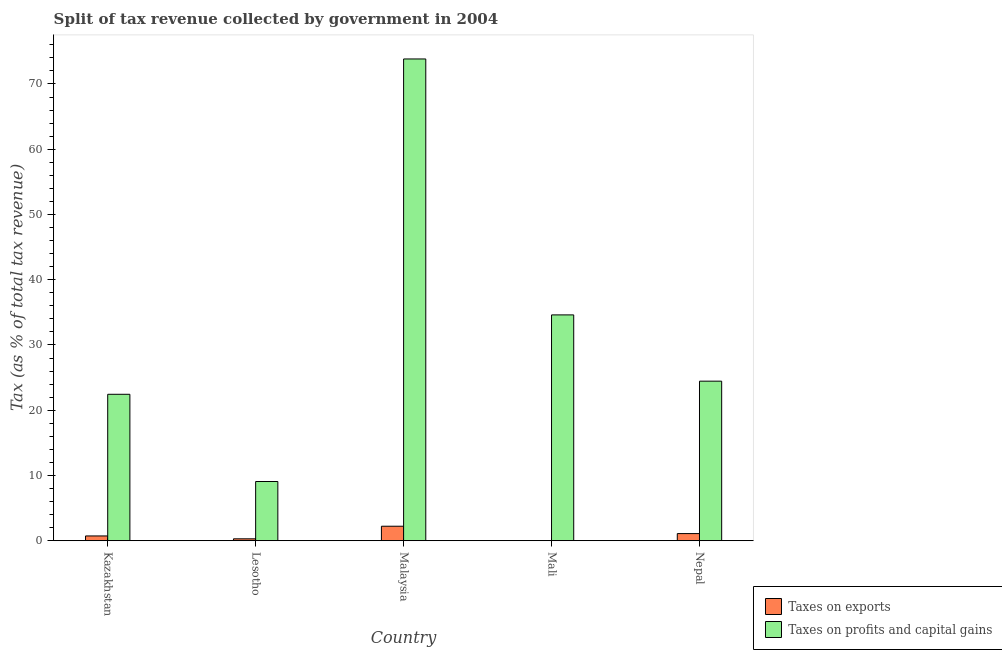How many different coloured bars are there?
Your answer should be compact. 2. Are the number of bars per tick equal to the number of legend labels?
Your answer should be very brief. Yes. How many bars are there on the 4th tick from the left?
Your response must be concise. 2. What is the label of the 3rd group of bars from the left?
Give a very brief answer. Malaysia. What is the percentage of revenue obtained from taxes on exports in Lesotho?
Offer a terse response. 0.29. Across all countries, what is the maximum percentage of revenue obtained from taxes on profits and capital gains?
Offer a very short reply. 73.83. Across all countries, what is the minimum percentage of revenue obtained from taxes on exports?
Offer a terse response. 0. In which country was the percentage of revenue obtained from taxes on exports maximum?
Provide a short and direct response. Malaysia. In which country was the percentage of revenue obtained from taxes on profits and capital gains minimum?
Offer a very short reply. Lesotho. What is the total percentage of revenue obtained from taxes on exports in the graph?
Your response must be concise. 4.34. What is the difference between the percentage of revenue obtained from taxes on exports in Kazakhstan and that in Nepal?
Your answer should be very brief. -0.36. What is the difference between the percentage of revenue obtained from taxes on exports in Malaysia and the percentage of revenue obtained from taxes on profits and capital gains in Mali?
Ensure brevity in your answer.  -32.39. What is the average percentage of revenue obtained from taxes on exports per country?
Ensure brevity in your answer.  0.87. What is the difference between the percentage of revenue obtained from taxes on profits and capital gains and percentage of revenue obtained from taxes on exports in Nepal?
Your answer should be very brief. 23.36. In how many countries, is the percentage of revenue obtained from taxes on exports greater than 34 %?
Give a very brief answer. 0. What is the ratio of the percentage of revenue obtained from taxes on profits and capital gains in Kazakhstan to that in Nepal?
Provide a short and direct response. 0.92. Is the percentage of revenue obtained from taxes on exports in Kazakhstan less than that in Nepal?
Your response must be concise. Yes. Is the difference between the percentage of revenue obtained from taxes on exports in Kazakhstan and Lesotho greater than the difference between the percentage of revenue obtained from taxes on profits and capital gains in Kazakhstan and Lesotho?
Make the answer very short. No. What is the difference between the highest and the second highest percentage of revenue obtained from taxes on profits and capital gains?
Provide a succinct answer. 39.22. What is the difference between the highest and the lowest percentage of revenue obtained from taxes on profits and capital gains?
Offer a terse response. 64.76. What does the 1st bar from the left in Malaysia represents?
Offer a terse response. Taxes on exports. What does the 1st bar from the right in Malaysia represents?
Your answer should be compact. Taxes on profits and capital gains. Are all the bars in the graph horizontal?
Offer a terse response. No. How many countries are there in the graph?
Give a very brief answer. 5. What is the difference between two consecutive major ticks on the Y-axis?
Your answer should be very brief. 10. Are the values on the major ticks of Y-axis written in scientific E-notation?
Provide a short and direct response. No. Where does the legend appear in the graph?
Your answer should be compact. Bottom right. How many legend labels are there?
Keep it short and to the point. 2. How are the legend labels stacked?
Your answer should be very brief. Vertical. What is the title of the graph?
Your answer should be very brief. Split of tax revenue collected by government in 2004. Does "Girls" appear as one of the legend labels in the graph?
Your response must be concise. No. What is the label or title of the Y-axis?
Provide a short and direct response. Tax (as % of total tax revenue). What is the Tax (as % of total tax revenue) of Taxes on exports in Kazakhstan?
Your answer should be very brief. 0.73. What is the Tax (as % of total tax revenue) in Taxes on profits and capital gains in Kazakhstan?
Give a very brief answer. 22.44. What is the Tax (as % of total tax revenue) in Taxes on exports in Lesotho?
Make the answer very short. 0.29. What is the Tax (as % of total tax revenue) in Taxes on profits and capital gains in Lesotho?
Make the answer very short. 9.07. What is the Tax (as % of total tax revenue) in Taxes on exports in Malaysia?
Offer a very short reply. 2.22. What is the Tax (as % of total tax revenue) of Taxes on profits and capital gains in Malaysia?
Your response must be concise. 73.83. What is the Tax (as % of total tax revenue) of Taxes on exports in Mali?
Your answer should be very brief. 0. What is the Tax (as % of total tax revenue) in Taxes on profits and capital gains in Mali?
Your answer should be very brief. 34.61. What is the Tax (as % of total tax revenue) in Taxes on exports in Nepal?
Keep it short and to the point. 1.09. What is the Tax (as % of total tax revenue) in Taxes on profits and capital gains in Nepal?
Provide a short and direct response. 24.45. Across all countries, what is the maximum Tax (as % of total tax revenue) of Taxes on exports?
Your answer should be very brief. 2.22. Across all countries, what is the maximum Tax (as % of total tax revenue) in Taxes on profits and capital gains?
Give a very brief answer. 73.83. Across all countries, what is the minimum Tax (as % of total tax revenue) in Taxes on exports?
Ensure brevity in your answer.  0. Across all countries, what is the minimum Tax (as % of total tax revenue) of Taxes on profits and capital gains?
Provide a succinct answer. 9.07. What is the total Tax (as % of total tax revenue) in Taxes on exports in the graph?
Give a very brief answer. 4.34. What is the total Tax (as % of total tax revenue) in Taxes on profits and capital gains in the graph?
Offer a terse response. 164.4. What is the difference between the Tax (as % of total tax revenue) in Taxes on exports in Kazakhstan and that in Lesotho?
Your answer should be compact. 0.44. What is the difference between the Tax (as % of total tax revenue) in Taxes on profits and capital gains in Kazakhstan and that in Lesotho?
Your answer should be very brief. 13.36. What is the difference between the Tax (as % of total tax revenue) in Taxes on exports in Kazakhstan and that in Malaysia?
Give a very brief answer. -1.49. What is the difference between the Tax (as % of total tax revenue) in Taxes on profits and capital gains in Kazakhstan and that in Malaysia?
Your answer should be very brief. -51.39. What is the difference between the Tax (as % of total tax revenue) of Taxes on exports in Kazakhstan and that in Mali?
Your response must be concise. 0.73. What is the difference between the Tax (as % of total tax revenue) of Taxes on profits and capital gains in Kazakhstan and that in Mali?
Offer a very short reply. -12.17. What is the difference between the Tax (as % of total tax revenue) of Taxes on exports in Kazakhstan and that in Nepal?
Provide a succinct answer. -0.36. What is the difference between the Tax (as % of total tax revenue) in Taxes on profits and capital gains in Kazakhstan and that in Nepal?
Make the answer very short. -2.01. What is the difference between the Tax (as % of total tax revenue) in Taxes on exports in Lesotho and that in Malaysia?
Give a very brief answer. -1.93. What is the difference between the Tax (as % of total tax revenue) in Taxes on profits and capital gains in Lesotho and that in Malaysia?
Offer a very short reply. -64.76. What is the difference between the Tax (as % of total tax revenue) in Taxes on exports in Lesotho and that in Mali?
Offer a terse response. 0.29. What is the difference between the Tax (as % of total tax revenue) of Taxes on profits and capital gains in Lesotho and that in Mali?
Provide a succinct answer. -25.53. What is the difference between the Tax (as % of total tax revenue) of Taxes on exports in Lesotho and that in Nepal?
Offer a very short reply. -0.8. What is the difference between the Tax (as % of total tax revenue) of Taxes on profits and capital gains in Lesotho and that in Nepal?
Provide a short and direct response. -15.38. What is the difference between the Tax (as % of total tax revenue) of Taxes on exports in Malaysia and that in Mali?
Provide a succinct answer. 2.22. What is the difference between the Tax (as % of total tax revenue) of Taxes on profits and capital gains in Malaysia and that in Mali?
Give a very brief answer. 39.22. What is the difference between the Tax (as % of total tax revenue) of Taxes on exports in Malaysia and that in Nepal?
Your answer should be very brief. 1.13. What is the difference between the Tax (as % of total tax revenue) in Taxes on profits and capital gains in Malaysia and that in Nepal?
Your answer should be compact. 49.38. What is the difference between the Tax (as % of total tax revenue) of Taxes on exports in Mali and that in Nepal?
Ensure brevity in your answer.  -1.09. What is the difference between the Tax (as % of total tax revenue) in Taxes on profits and capital gains in Mali and that in Nepal?
Your answer should be very brief. 10.16. What is the difference between the Tax (as % of total tax revenue) in Taxes on exports in Kazakhstan and the Tax (as % of total tax revenue) in Taxes on profits and capital gains in Lesotho?
Provide a succinct answer. -8.34. What is the difference between the Tax (as % of total tax revenue) in Taxes on exports in Kazakhstan and the Tax (as % of total tax revenue) in Taxes on profits and capital gains in Malaysia?
Offer a terse response. -73.1. What is the difference between the Tax (as % of total tax revenue) in Taxes on exports in Kazakhstan and the Tax (as % of total tax revenue) in Taxes on profits and capital gains in Mali?
Offer a very short reply. -33.88. What is the difference between the Tax (as % of total tax revenue) of Taxes on exports in Kazakhstan and the Tax (as % of total tax revenue) of Taxes on profits and capital gains in Nepal?
Your response must be concise. -23.72. What is the difference between the Tax (as % of total tax revenue) of Taxes on exports in Lesotho and the Tax (as % of total tax revenue) of Taxes on profits and capital gains in Malaysia?
Keep it short and to the point. -73.54. What is the difference between the Tax (as % of total tax revenue) of Taxes on exports in Lesotho and the Tax (as % of total tax revenue) of Taxes on profits and capital gains in Mali?
Your answer should be very brief. -34.32. What is the difference between the Tax (as % of total tax revenue) of Taxes on exports in Lesotho and the Tax (as % of total tax revenue) of Taxes on profits and capital gains in Nepal?
Provide a succinct answer. -24.16. What is the difference between the Tax (as % of total tax revenue) in Taxes on exports in Malaysia and the Tax (as % of total tax revenue) in Taxes on profits and capital gains in Mali?
Your response must be concise. -32.39. What is the difference between the Tax (as % of total tax revenue) in Taxes on exports in Malaysia and the Tax (as % of total tax revenue) in Taxes on profits and capital gains in Nepal?
Offer a very short reply. -22.23. What is the difference between the Tax (as % of total tax revenue) of Taxes on exports in Mali and the Tax (as % of total tax revenue) of Taxes on profits and capital gains in Nepal?
Ensure brevity in your answer.  -24.45. What is the average Tax (as % of total tax revenue) of Taxes on exports per country?
Ensure brevity in your answer.  0.87. What is the average Tax (as % of total tax revenue) in Taxes on profits and capital gains per country?
Ensure brevity in your answer.  32.88. What is the difference between the Tax (as % of total tax revenue) in Taxes on exports and Tax (as % of total tax revenue) in Taxes on profits and capital gains in Kazakhstan?
Your response must be concise. -21.71. What is the difference between the Tax (as % of total tax revenue) in Taxes on exports and Tax (as % of total tax revenue) in Taxes on profits and capital gains in Lesotho?
Provide a succinct answer. -8.78. What is the difference between the Tax (as % of total tax revenue) of Taxes on exports and Tax (as % of total tax revenue) of Taxes on profits and capital gains in Malaysia?
Offer a very short reply. -71.61. What is the difference between the Tax (as % of total tax revenue) in Taxes on exports and Tax (as % of total tax revenue) in Taxes on profits and capital gains in Mali?
Make the answer very short. -34.61. What is the difference between the Tax (as % of total tax revenue) in Taxes on exports and Tax (as % of total tax revenue) in Taxes on profits and capital gains in Nepal?
Offer a terse response. -23.36. What is the ratio of the Tax (as % of total tax revenue) of Taxes on exports in Kazakhstan to that in Lesotho?
Offer a very short reply. 2.51. What is the ratio of the Tax (as % of total tax revenue) of Taxes on profits and capital gains in Kazakhstan to that in Lesotho?
Provide a succinct answer. 2.47. What is the ratio of the Tax (as % of total tax revenue) in Taxes on exports in Kazakhstan to that in Malaysia?
Provide a short and direct response. 0.33. What is the ratio of the Tax (as % of total tax revenue) in Taxes on profits and capital gains in Kazakhstan to that in Malaysia?
Make the answer very short. 0.3. What is the ratio of the Tax (as % of total tax revenue) of Taxes on exports in Kazakhstan to that in Mali?
Offer a terse response. 652.2. What is the ratio of the Tax (as % of total tax revenue) of Taxes on profits and capital gains in Kazakhstan to that in Mali?
Provide a succinct answer. 0.65. What is the ratio of the Tax (as % of total tax revenue) of Taxes on exports in Kazakhstan to that in Nepal?
Your response must be concise. 0.67. What is the ratio of the Tax (as % of total tax revenue) of Taxes on profits and capital gains in Kazakhstan to that in Nepal?
Your answer should be compact. 0.92. What is the ratio of the Tax (as % of total tax revenue) of Taxes on exports in Lesotho to that in Malaysia?
Make the answer very short. 0.13. What is the ratio of the Tax (as % of total tax revenue) in Taxes on profits and capital gains in Lesotho to that in Malaysia?
Provide a succinct answer. 0.12. What is the ratio of the Tax (as % of total tax revenue) of Taxes on exports in Lesotho to that in Mali?
Provide a succinct answer. 259.92. What is the ratio of the Tax (as % of total tax revenue) of Taxes on profits and capital gains in Lesotho to that in Mali?
Your answer should be compact. 0.26. What is the ratio of the Tax (as % of total tax revenue) in Taxes on exports in Lesotho to that in Nepal?
Provide a succinct answer. 0.27. What is the ratio of the Tax (as % of total tax revenue) of Taxes on profits and capital gains in Lesotho to that in Nepal?
Provide a short and direct response. 0.37. What is the ratio of the Tax (as % of total tax revenue) of Taxes on exports in Malaysia to that in Mali?
Offer a very short reply. 1981.76. What is the ratio of the Tax (as % of total tax revenue) of Taxes on profits and capital gains in Malaysia to that in Mali?
Provide a short and direct response. 2.13. What is the ratio of the Tax (as % of total tax revenue) in Taxes on exports in Malaysia to that in Nepal?
Your response must be concise. 2.03. What is the ratio of the Tax (as % of total tax revenue) in Taxes on profits and capital gains in Malaysia to that in Nepal?
Offer a very short reply. 3.02. What is the ratio of the Tax (as % of total tax revenue) in Taxes on exports in Mali to that in Nepal?
Provide a short and direct response. 0. What is the ratio of the Tax (as % of total tax revenue) of Taxes on profits and capital gains in Mali to that in Nepal?
Ensure brevity in your answer.  1.42. What is the difference between the highest and the second highest Tax (as % of total tax revenue) of Taxes on exports?
Offer a very short reply. 1.13. What is the difference between the highest and the second highest Tax (as % of total tax revenue) of Taxes on profits and capital gains?
Keep it short and to the point. 39.22. What is the difference between the highest and the lowest Tax (as % of total tax revenue) of Taxes on exports?
Make the answer very short. 2.22. What is the difference between the highest and the lowest Tax (as % of total tax revenue) of Taxes on profits and capital gains?
Your response must be concise. 64.76. 